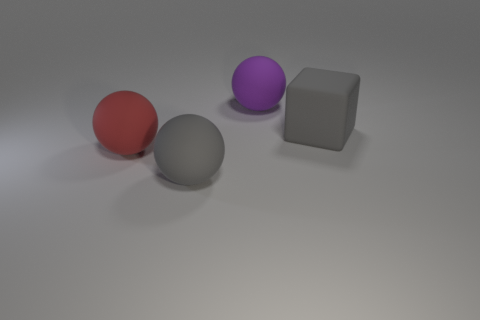Subtract 1 balls. How many balls are left? 2 Add 3 large cyan rubber cylinders. How many objects exist? 7 Subtract all cubes. How many objects are left? 3 Subtract all small purple matte cubes. Subtract all big matte blocks. How many objects are left? 3 Add 1 gray balls. How many gray balls are left? 2 Add 4 red matte cylinders. How many red matte cylinders exist? 4 Subtract 0 brown cubes. How many objects are left? 4 